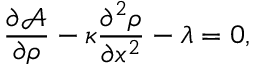Convert formula to latex. <formula><loc_0><loc_0><loc_500><loc_500>\frac { \partial \mathcal { A } } { \partial \rho } - \kappa \frac { \partial ^ { 2 } \rho } { \partial x ^ { 2 } } - \lambda = 0 ,</formula> 